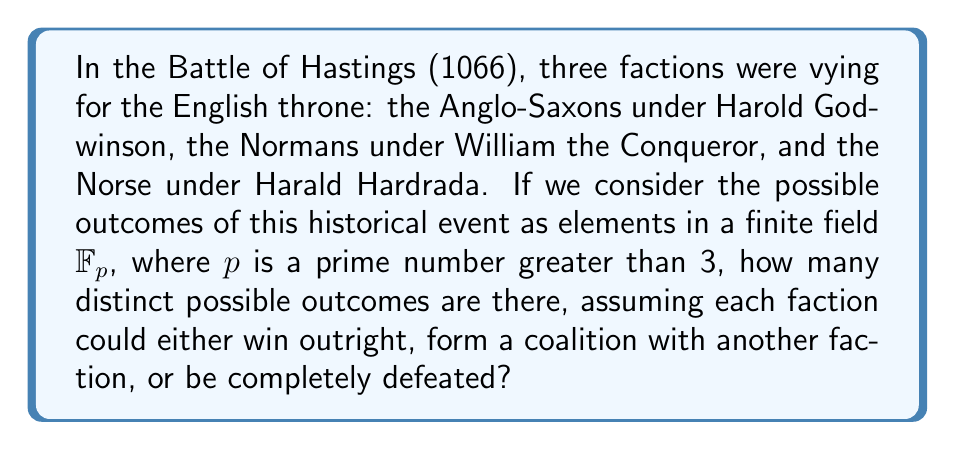Can you solve this math problem? Let's approach this step-by-step using concepts from field theory:

1) First, we need to identify the possible outcomes:
   - Each faction winning outright: 3 possibilities
   - Two-faction coalitions: $\binom{3}{2} = 3$ possibilities
   - Complete defeat for all: 1 possibility

2) Total number of distinct outcomes: $3 + 3 + 1 = 7$

3) In field theory, we're working with $\mathbb{F}_p$, where $p$ is prime and $p > 3$. The number of elements in $\mathbb{F}_p$ is always $p$.

4) For our historical scenario to be represented in $\mathbb{F}_p$, we need $p \geq 7$ to accommodate all possible outcomes.

5) The smallest prime $p$ that satisfies this condition is 7.

6) In $\mathbb{F}_7$, we can represent our outcomes as follows:
   - 0: Complete defeat for all
   - 1, 2, 3: Individual faction victories
   - 4, 5, 6: Two-faction coalitions

7) Therefore, the number of possible outcomes in our field theoretical representation is 7, which corresponds to the number of elements in $\mathbb{F}_7$.
Answer: 7 